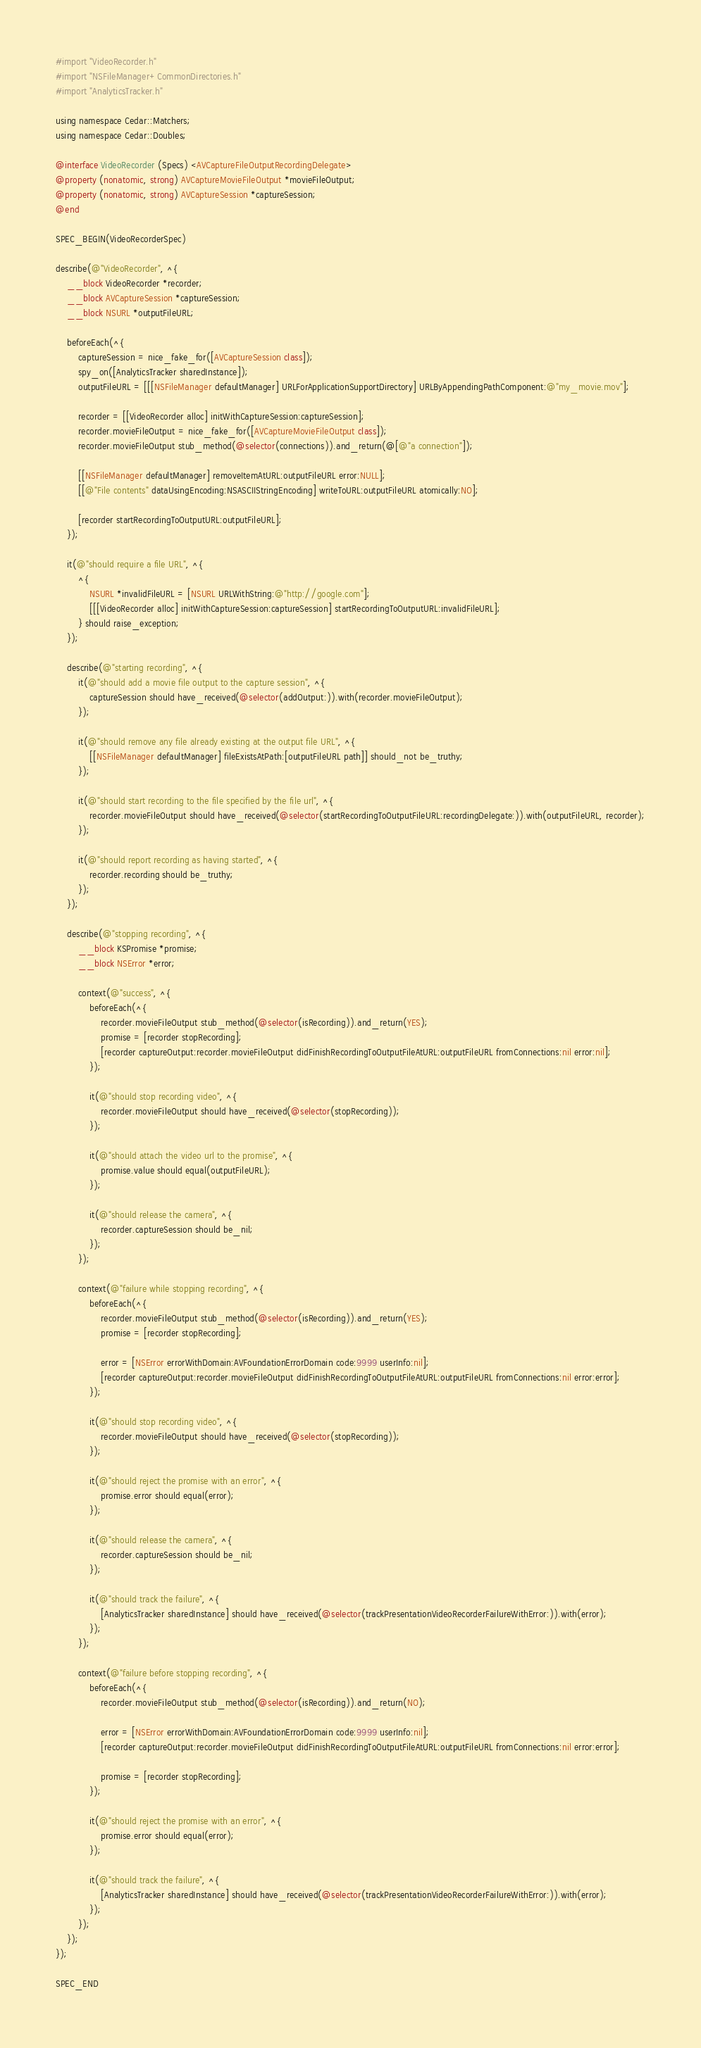<code> <loc_0><loc_0><loc_500><loc_500><_ObjectiveC_>#import "VideoRecorder.h"
#import "NSFileManager+CommonDirectories.h"
#import "AnalyticsTracker.h"

using namespace Cedar::Matchers;
using namespace Cedar::Doubles;

@interface VideoRecorder (Specs) <AVCaptureFileOutputRecordingDelegate>
@property (nonatomic, strong) AVCaptureMovieFileOutput *movieFileOutput;
@property (nonatomic, strong) AVCaptureSession *captureSession;
@end

SPEC_BEGIN(VideoRecorderSpec)

describe(@"VideoRecorder", ^{
    __block VideoRecorder *recorder;
    __block AVCaptureSession *captureSession;
    __block NSURL *outputFileURL;

    beforeEach(^{
        captureSession = nice_fake_for([AVCaptureSession class]);
        spy_on([AnalyticsTracker sharedInstance]);
        outputFileURL = [[[NSFileManager defaultManager] URLForApplicationSupportDirectory] URLByAppendingPathComponent:@"my_movie.mov"];

        recorder = [[VideoRecorder alloc] initWithCaptureSession:captureSession];
        recorder.movieFileOutput = nice_fake_for([AVCaptureMovieFileOutput class]);
        recorder.movieFileOutput stub_method(@selector(connections)).and_return(@[@"a connection"]);

        [[NSFileManager defaultManager] removeItemAtURL:outputFileURL error:NULL];
        [[@"File contents" dataUsingEncoding:NSASCIIStringEncoding] writeToURL:outputFileURL atomically:NO];

        [recorder startRecordingToOutputURL:outputFileURL];
    });

    it(@"should require a file URL", ^{
        ^{
            NSURL *invalidFileURL = [NSURL URLWithString:@"http://google.com"];
            [[[VideoRecorder alloc] initWithCaptureSession:captureSession] startRecordingToOutputURL:invalidFileURL];
        } should raise_exception;
    });

    describe(@"starting recording", ^{
        it(@"should add a movie file output to the capture session", ^{
            captureSession should have_received(@selector(addOutput:)).with(recorder.movieFileOutput);
        });

        it(@"should remove any file already existing at the output file URL", ^{
            [[NSFileManager defaultManager] fileExistsAtPath:[outputFileURL path]] should_not be_truthy;
        });

        it(@"should start recording to the file specified by the file url", ^{
            recorder.movieFileOutput should have_received(@selector(startRecordingToOutputFileURL:recordingDelegate:)).with(outputFileURL, recorder);
        });

        it(@"should report recording as having started", ^{
            recorder.recording should be_truthy;
        });
    });

    describe(@"stopping recording", ^{
        __block KSPromise *promise;
        __block NSError *error;

        context(@"success", ^{
            beforeEach(^{
                recorder.movieFileOutput stub_method(@selector(isRecording)).and_return(YES);
                promise = [recorder stopRecording];
                [recorder captureOutput:recorder.movieFileOutput didFinishRecordingToOutputFileAtURL:outputFileURL fromConnections:nil error:nil];
            });

            it(@"should stop recording video", ^{
                recorder.movieFileOutput should have_received(@selector(stopRecording));
            });

            it(@"should attach the video url to the promise", ^{
                promise.value should equal(outputFileURL);
            });

            it(@"should release the camera", ^{
                recorder.captureSession should be_nil;
            });
        });

        context(@"failure while stopping recording", ^{
            beforeEach(^{
                recorder.movieFileOutput stub_method(@selector(isRecording)).and_return(YES);
                promise = [recorder stopRecording];

                error = [NSError errorWithDomain:AVFoundationErrorDomain code:9999 userInfo:nil];
                [recorder captureOutput:recorder.movieFileOutput didFinishRecordingToOutputFileAtURL:outputFileURL fromConnections:nil error:error];
            });

            it(@"should stop recording video", ^{
                recorder.movieFileOutput should have_received(@selector(stopRecording));
            });

            it(@"should reject the promise with an error", ^{
                promise.error should equal(error);
            });

            it(@"should release the camera", ^{
                recorder.captureSession should be_nil;
            });

            it(@"should track the failure", ^{
                [AnalyticsTracker sharedInstance] should have_received(@selector(trackPresentationVideoRecorderFailureWithError:)).with(error);
            });
        });

        context(@"failure before stopping recording", ^{
            beforeEach(^{
                recorder.movieFileOutput stub_method(@selector(isRecording)).and_return(NO);

                error = [NSError errorWithDomain:AVFoundationErrorDomain code:9999 userInfo:nil];
                [recorder captureOutput:recorder.movieFileOutput didFinishRecordingToOutputFileAtURL:outputFileURL fromConnections:nil error:error];

                promise = [recorder stopRecording];
            });

            it(@"should reject the promise with an error", ^{
                promise.error should equal(error);
            });

            it(@"should track the failure", ^{
                [AnalyticsTracker sharedInstance] should have_received(@selector(trackPresentationVideoRecorderFailureWithError:)).with(error);
            });
        });
    });
});

SPEC_END
</code> 